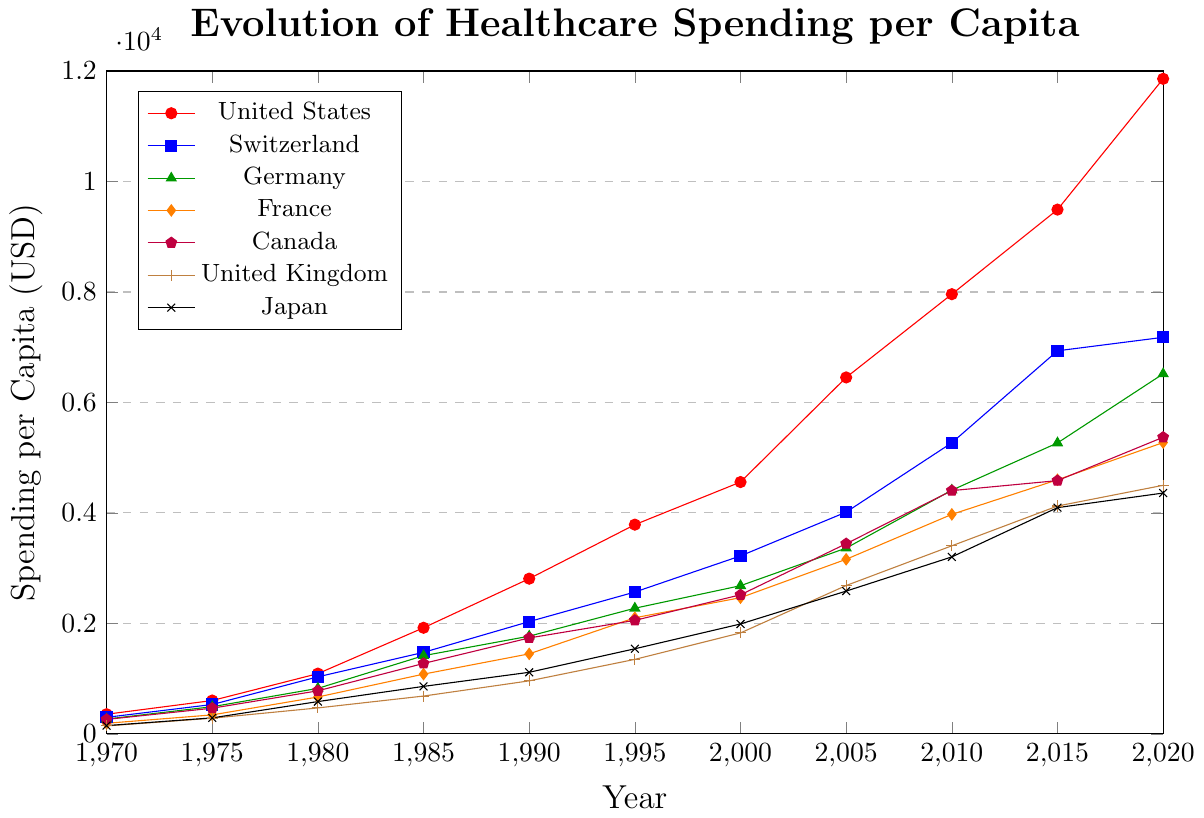What is the spending per capita for Germany in 2020? Look for the coordinate (2020, 6518) on the line representing Germany.
Answer: 6518 Which country had the highest healthcare spending per capita in 2020? Compare the spending per capita values for all the countries in 2020. The United States has the highest value, 11859 USD.
Answer: United States By how much did the healthcare spending per capita in Switzerland increase from 1970 to 2020? Subtract Switzerland's spending in 1970 (300) from its spending in 2020 (7179). 7179 - 300 = 6879.
Answer: 6879 Which countries had higher healthcare spending per capita than Japan in 2015? Note Japan's spending in 2015 (4096) and compare it with the values for other countries in 2015 (9491, 6935, 5267, 4600, 4585, 4125). The United States, Switzerland, Germany, France, Canada, and the United Kingdom all had higher values.
Answer: United States, Switzerland, Germany, France, Canada, United Kingdom What is the average healthcare spending per capita of the United Kingdom for the years provided? Sum the United Kingdom's spending values and divide by the number of years: (144 + 284 + 470 + 685 + 960 + 1349 + 1828 + 2686 + 3405 + 4125 + 4500)/11.
Answer: 1804.7 In which year did France's healthcare spending per capita first exceed 1000 USD? Locate the year when France's data crosses 1000 USD. It first exceeds 1000 USD in 1985 (1082).
Answer: 1985 Which country had the greatest increase in healthcare spending per capita from 2015 to 2020? Subtract the 2015 values from the 2020 values for all countries, and find the country with the maximum difference. United States: 11859 - 9491 = 2368, Switzerland: 7179 - 6935 = 244, Germany: 6518 - 5267 = 1251, etc. The United States has the greatest increase of 2368.
Answer: United States Compare the healthcare spending per capita for Germany and Canada in 1980. Which country spent more? Look at the values for Germany (824) and Canada (780) in 1980. Germany spent more.
Answer: Germany What is the median healthcare spending per capita across all countries in 2000? List the spending values in 2000 (4559, 3222, 2683, 2466, 2518, 1828, 1990), order them (1828, 1990, 2466, 2518, 2683, 3222, 4559), and find the middle value.
Answer: 2518 Which country had the lowest healthcare spending per capita in 1970? Compare the spending values in 1970 (356, 300, 269, 192, 262, 144, 150). The United Kingdom had the lowest, 144.
Answer: United Kingdom 